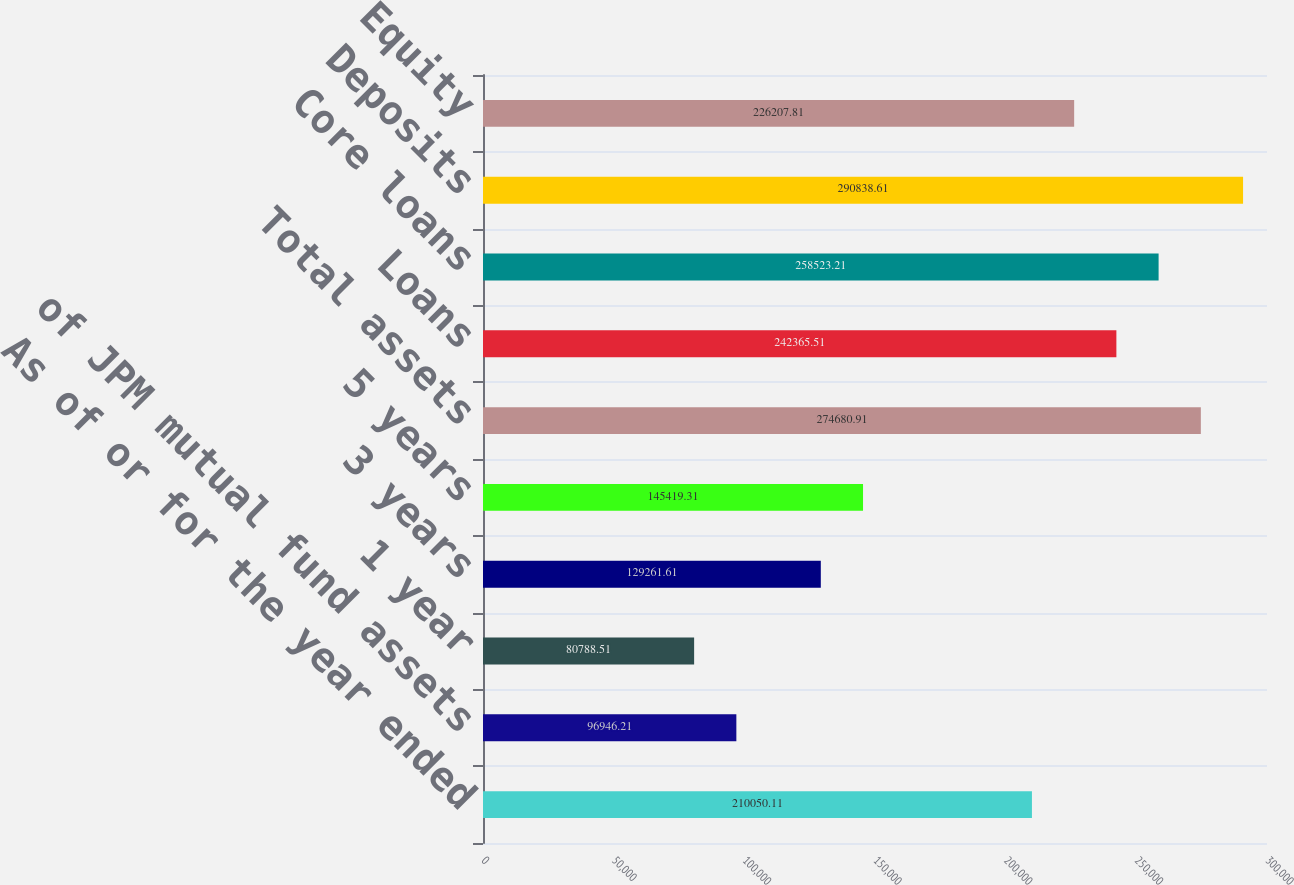<chart> <loc_0><loc_0><loc_500><loc_500><bar_chart><fcel>As of or for the year ended<fcel>of JPM mutual fund assets<fcel>1 year<fcel>3 years<fcel>5 years<fcel>Total assets<fcel>Loans<fcel>Core loans<fcel>Deposits<fcel>Equity<nl><fcel>210050<fcel>96946.2<fcel>80788.5<fcel>129262<fcel>145419<fcel>274681<fcel>242366<fcel>258523<fcel>290839<fcel>226208<nl></chart> 